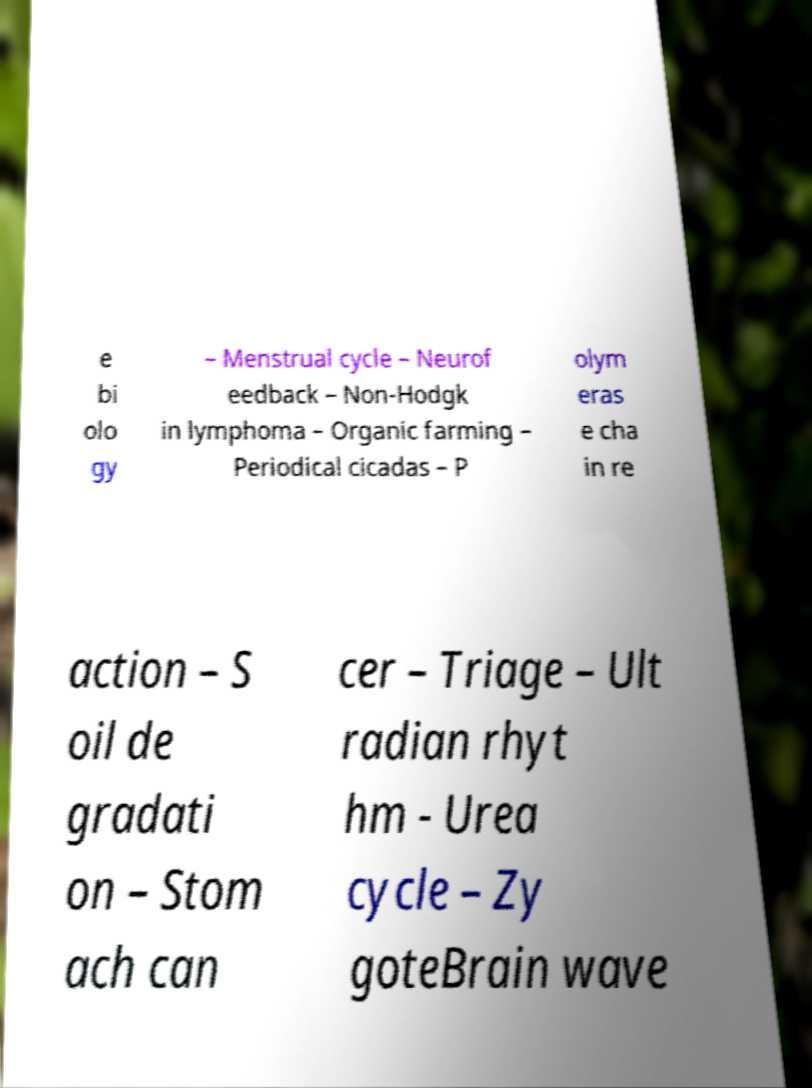Could you extract and type out the text from this image? e bi olo gy – Menstrual cycle – Neurof eedback – Non-Hodgk in lymphoma – Organic farming – Periodical cicadas – P olym eras e cha in re action – S oil de gradati on – Stom ach can cer – Triage – Ult radian rhyt hm - Urea cycle – Zy goteBrain wave 